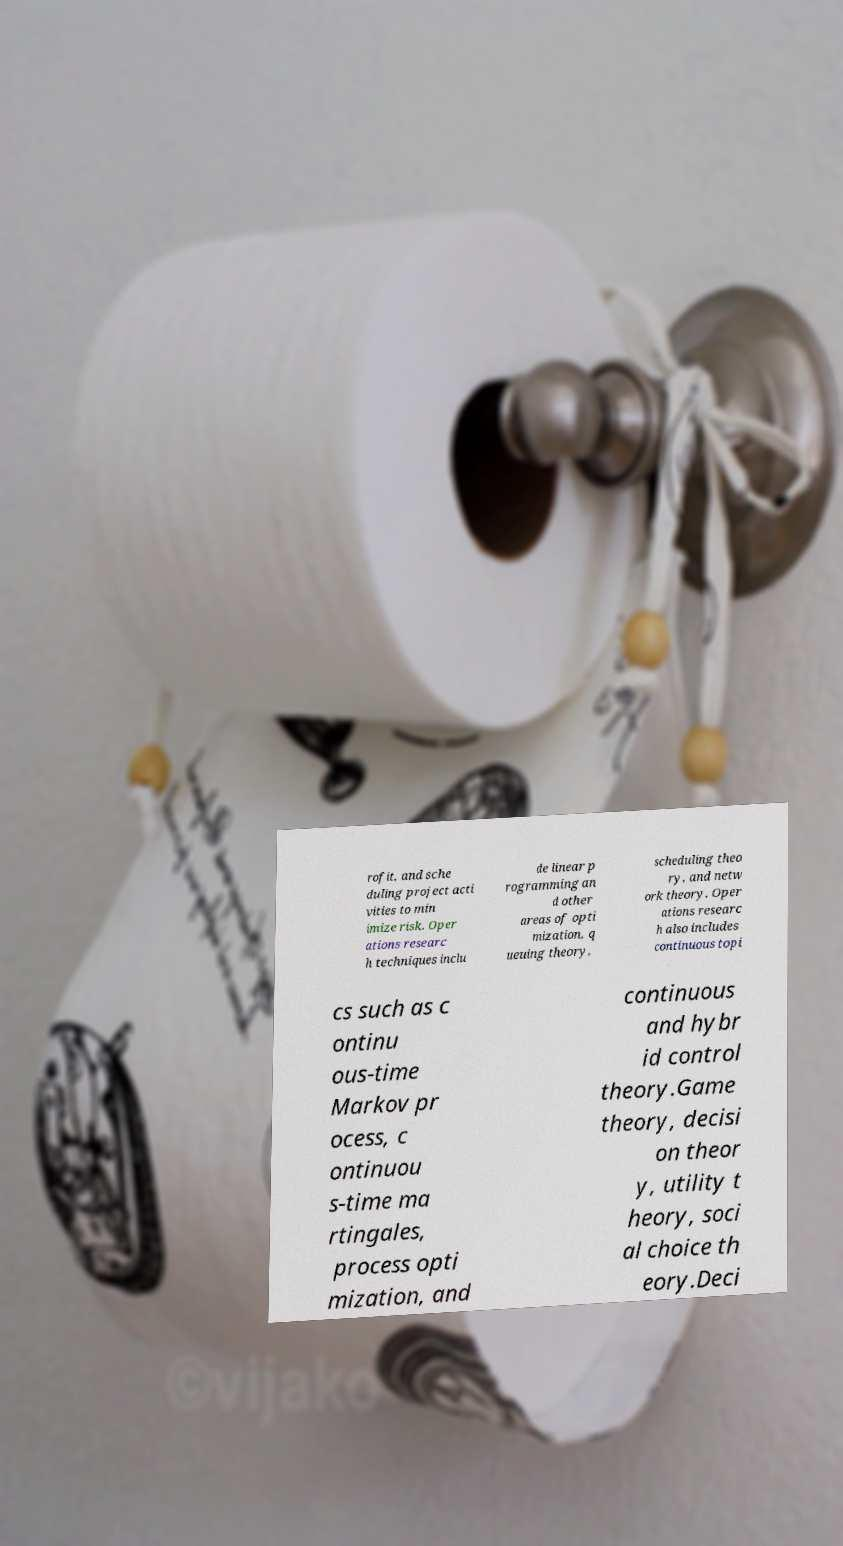Can you read and provide the text displayed in the image?This photo seems to have some interesting text. Can you extract and type it out for me? rofit, and sche duling project acti vities to min imize risk. Oper ations researc h techniques inclu de linear p rogramming an d other areas of opti mization, q ueuing theory, scheduling theo ry, and netw ork theory. Oper ations researc h also includes continuous topi cs such as c ontinu ous-time Markov pr ocess, c ontinuou s-time ma rtingales, process opti mization, and continuous and hybr id control theory.Game theory, decisi on theor y, utility t heory, soci al choice th eory.Deci 